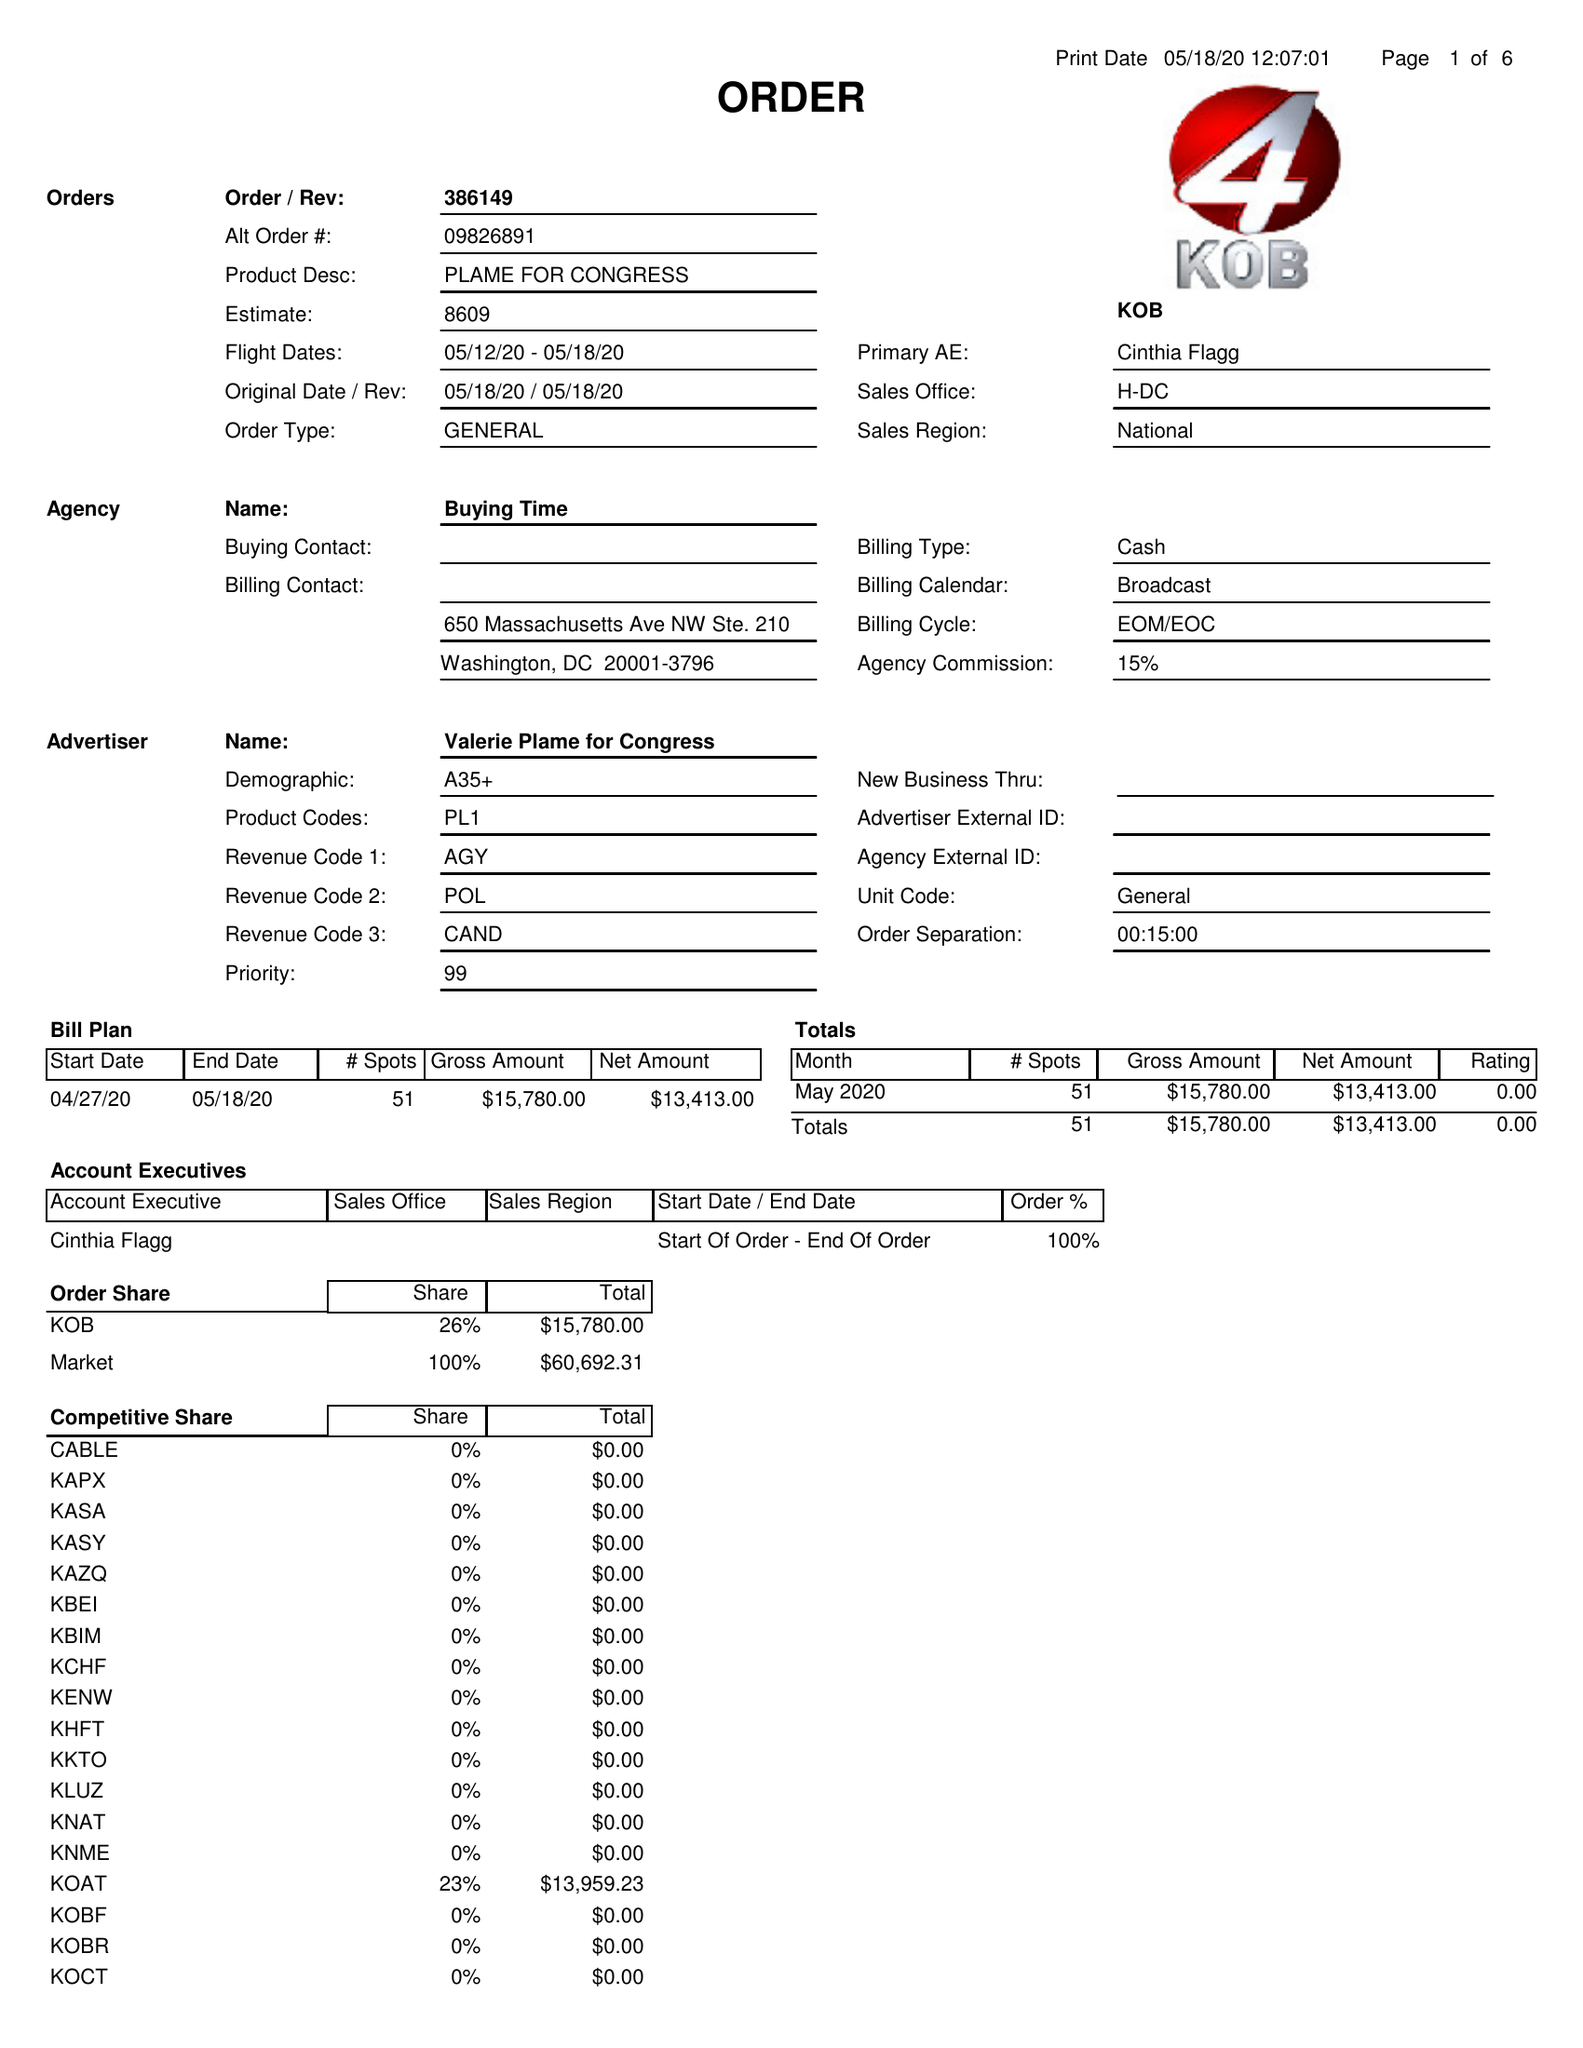What is the value for the flight_to?
Answer the question using a single word or phrase. 05/18/20 